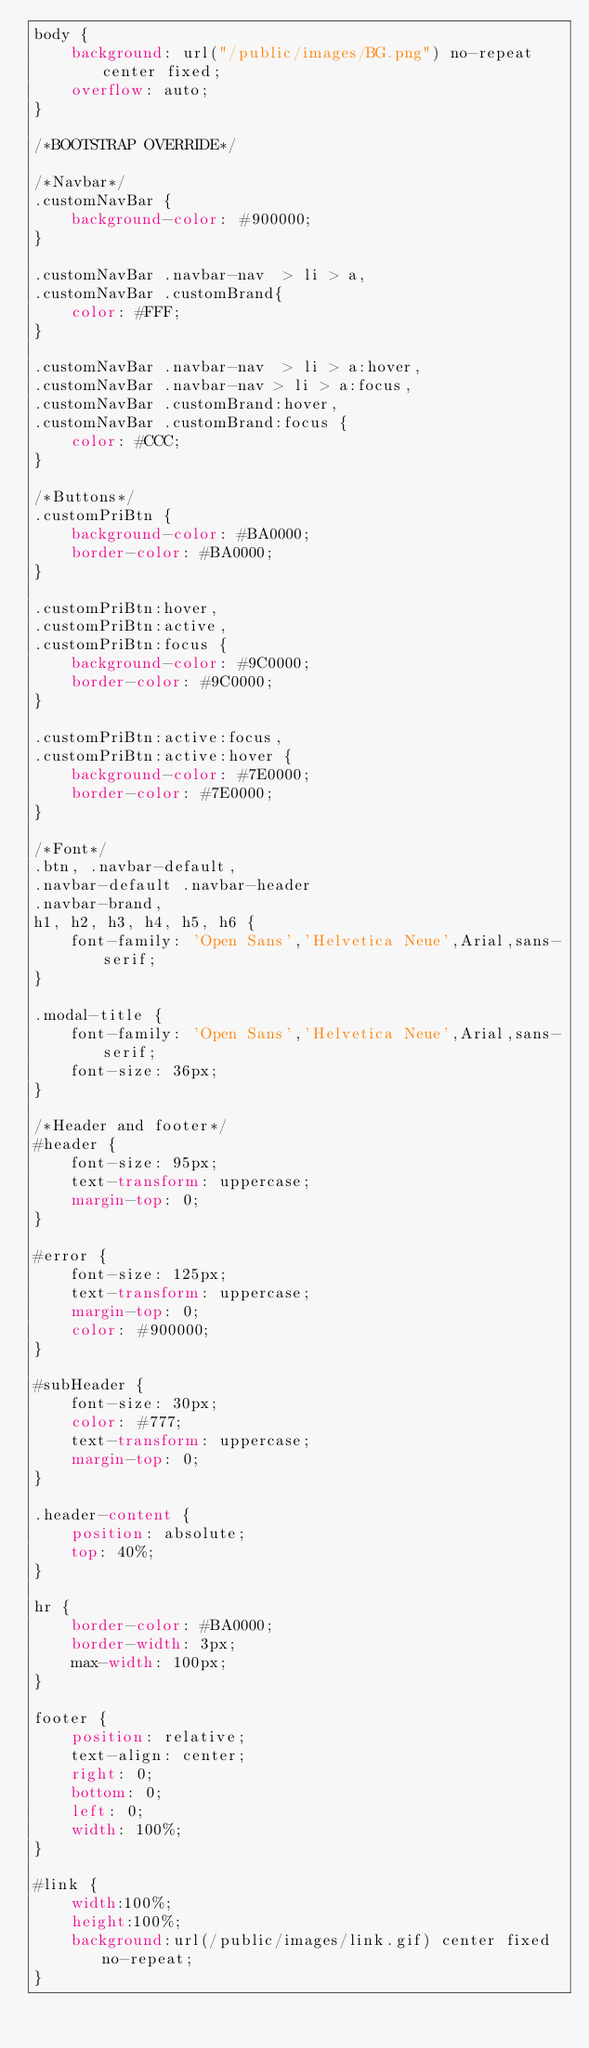<code> <loc_0><loc_0><loc_500><loc_500><_CSS_>body {
    background: url("/public/images/BG.png") no-repeat center fixed;
    overflow: auto;
}

/*BOOTSTRAP OVERRIDE*/

/*Navbar*/
.customNavBar {
    background-color: #900000;
}

.customNavBar .navbar-nav  > li > a, 
.customNavBar .customBrand{
    color: #FFF;
}

.customNavBar .navbar-nav  > li > a:hover, 
.customNavBar .navbar-nav > li > a:focus, 
.customNavBar .customBrand:hover, 
.customNavBar .customBrand:focus {
    color: #CCC;
}

/*Buttons*/
.customPriBtn {
    background-color: #BA0000;
    border-color: #BA0000;
}

.customPriBtn:hover, 
.customPriBtn:active, 
.customPriBtn:focus {
    background-color: #9C0000;
    border-color: #9C0000;
}

.customPriBtn:active:focus, 
.customPriBtn:active:hover {
    background-color: #7E0000;
    border-color: #7E0000;
}

/*Font*/
.btn, .navbar-default, 
.navbar-default .navbar-header 
.navbar-brand, 
h1, h2, h3, h4, h5, h6 {
    font-family: 'Open Sans','Helvetica Neue',Arial,sans-serif;
}

.modal-title {
    font-family: 'Open Sans','Helvetica Neue',Arial,sans-serif;
    font-size: 36px;    
}

/*Header and footer*/
#header {
    font-size: 95px;
    text-transform: uppercase;
    margin-top: 0;
}

#error {
    font-size: 125px;
    text-transform: uppercase;
    margin-top: 0;
    color: #900000;
}

#subHeader {
    font-size: 30px;
    color: #777;
    text-transform: uppercase;
    margin-top: 0;
}

.header-content {
    position: absolute;
    top: 40%;
}

hr {
    border-color: #BA0000;
    border-width: 3px;
    max-width: 100px;
}

footer {
    position: relative;
    text-align: center;
    right: 0;
    bottom: 0;
    left: 0;
    width: 100%;
}

#link {
    width:100%; 
    height:100%; 
    background:url(/public/images/link.gif) center fixed no-repeat;
}
</code> 